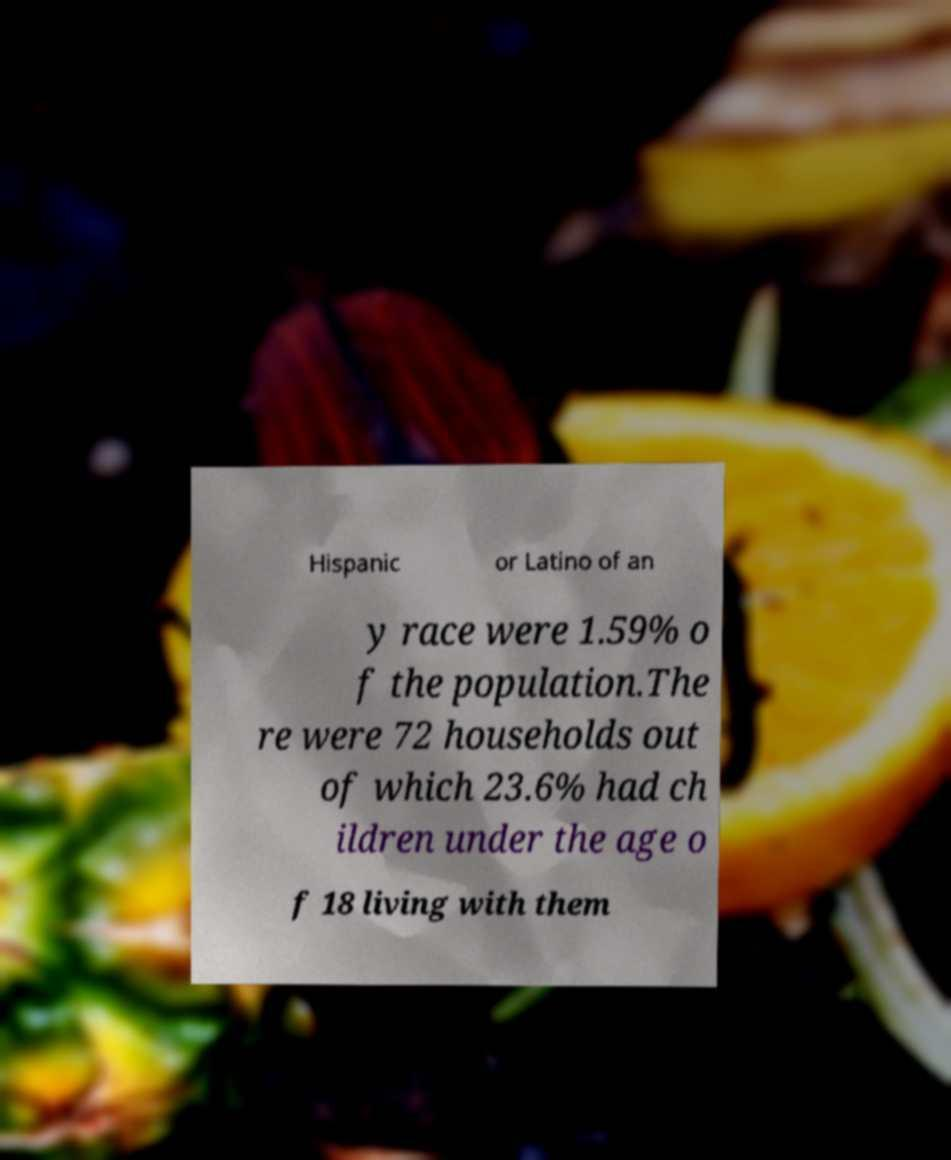Please identify and transcribe the text found in this image. Hispanic or Latino of an y race were 1.59% o f the population.The re were 72 households out of which 23.6% had ch ildren under the age o f 18 living with them 